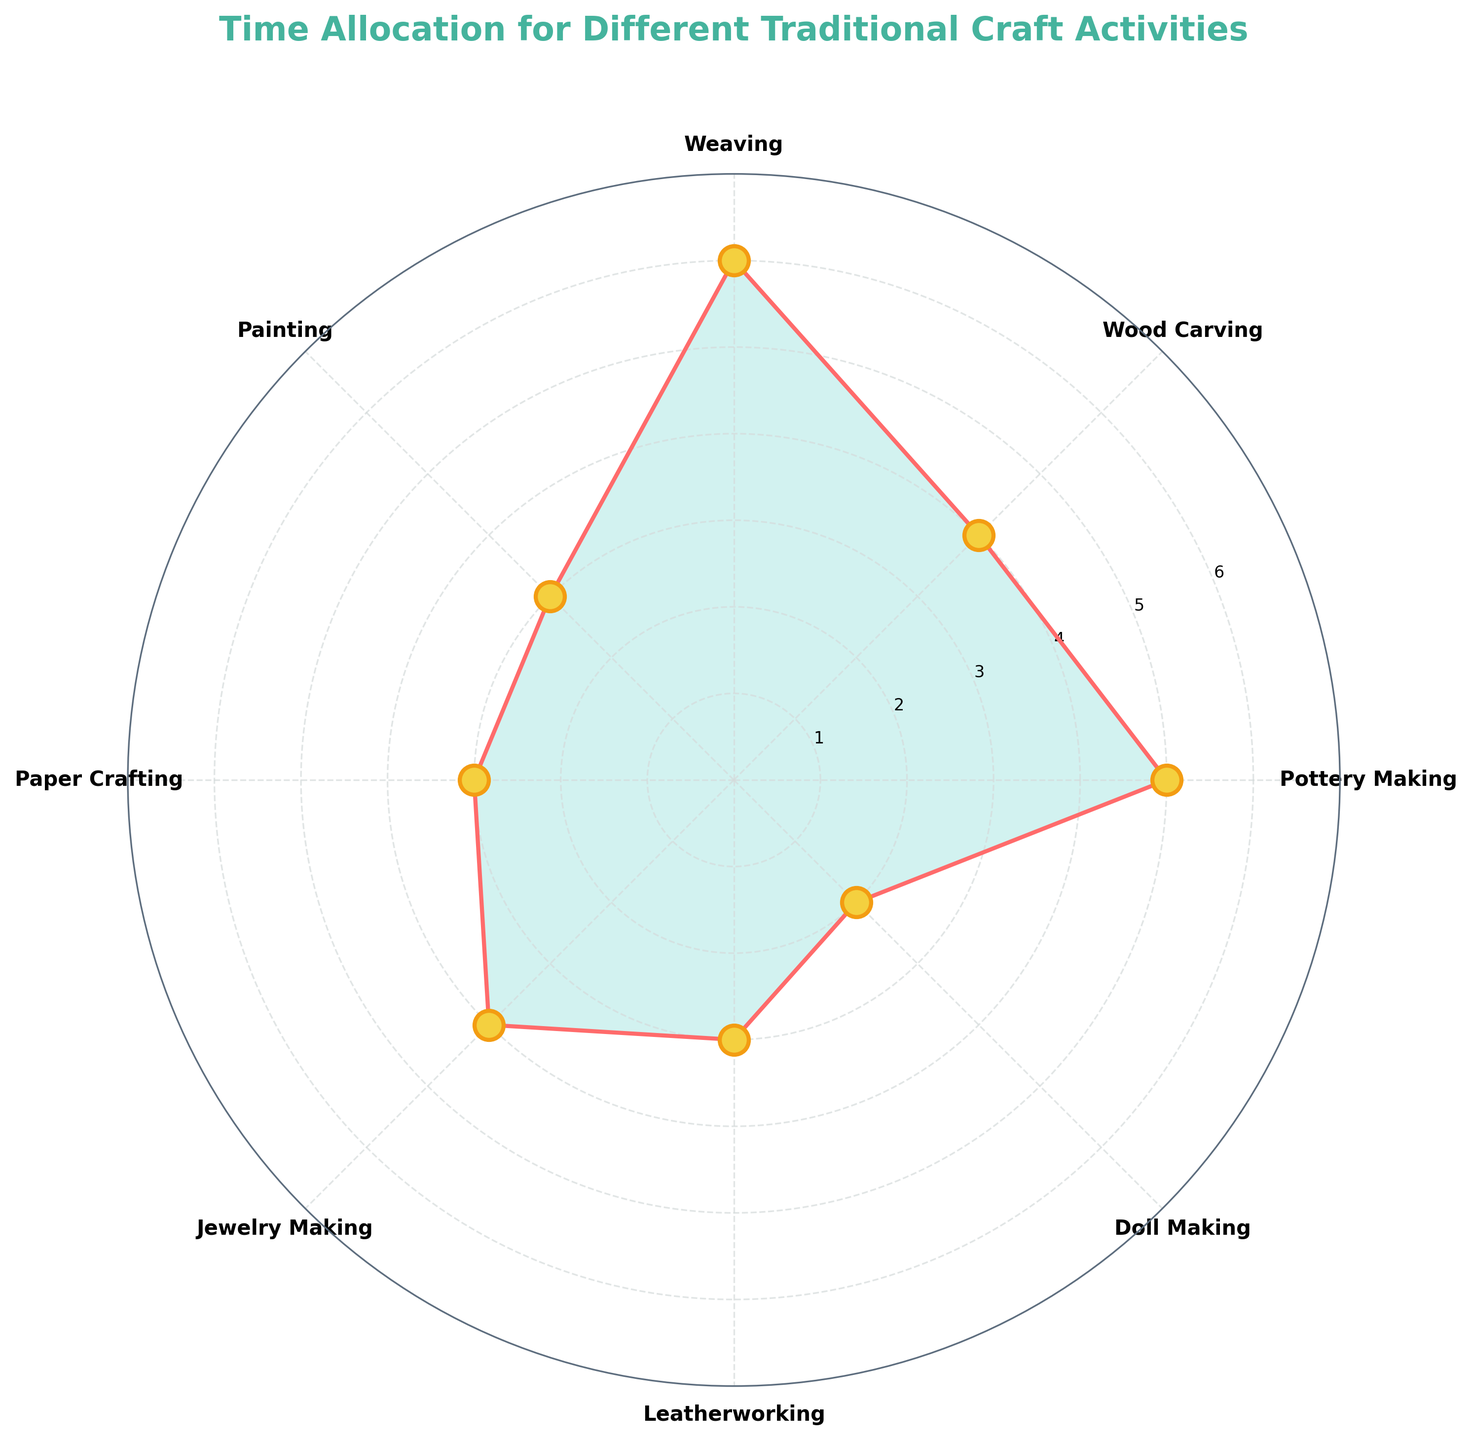What's the title of the chart? The title is displayed at the top of the chart and is typically the most prominent text. Here, it is positioned above the plot with a larger font size and different color.
Answer: Time Allocation for Different Traditional Craft Activities How many hours per week are spent on Weaving? Locate the label "Weaving" and follow the corresponding radial line to find the value on the y-axis.
Answer: 6 Which activity has the least amount of time allocated? Find the activity with the smallest radial extent from the center of the polar plot.
Answer: Doll Making How many activities have 3 hours allocated to them? Identify the number of different activities whose radial lines reach the y-axis value of 3.
Answer: Three (Painting, Paper Crafting, Leatherworking) How does the time allocated to Pottery Making compare to Wood Carving? Locate both activities and compare the lengths of their radial lines to see which extends further from the center.
Answer: Pottery Making has 1 hour more than Wood Carving What's the sum of hours allocated to Painting, Paper Crafting, and Leatherworking? Find the hours for each activity and add them together: Painting (3), Paper Crafting (3), Leatherworking (3). 3 + 3 + 3 = 9
Answer: 9 What is the average time allocated for all activities? Sum the hours for all activities and divide by the number of activities. (5 + 4 + 6 + 3 + 3 + 4 + 3 + 2) / 8 = 30 / 8 = 3.75
Answer: 3.75 Which activities have equal time allocation? Look for activities with the same radial line length.
Answer: Wood Carving and Jewelry Making; Painting, Paper Crafting, and Leatherworking Which activity takes up more time: Doll Making or Jewelry Making? Locate both activities and compare their radial extents.
Answer: Jewelry Making What is the maximum number of hours allocated to a single activity? Find the activity with the longest radial line and read its value.
Answer: 6 